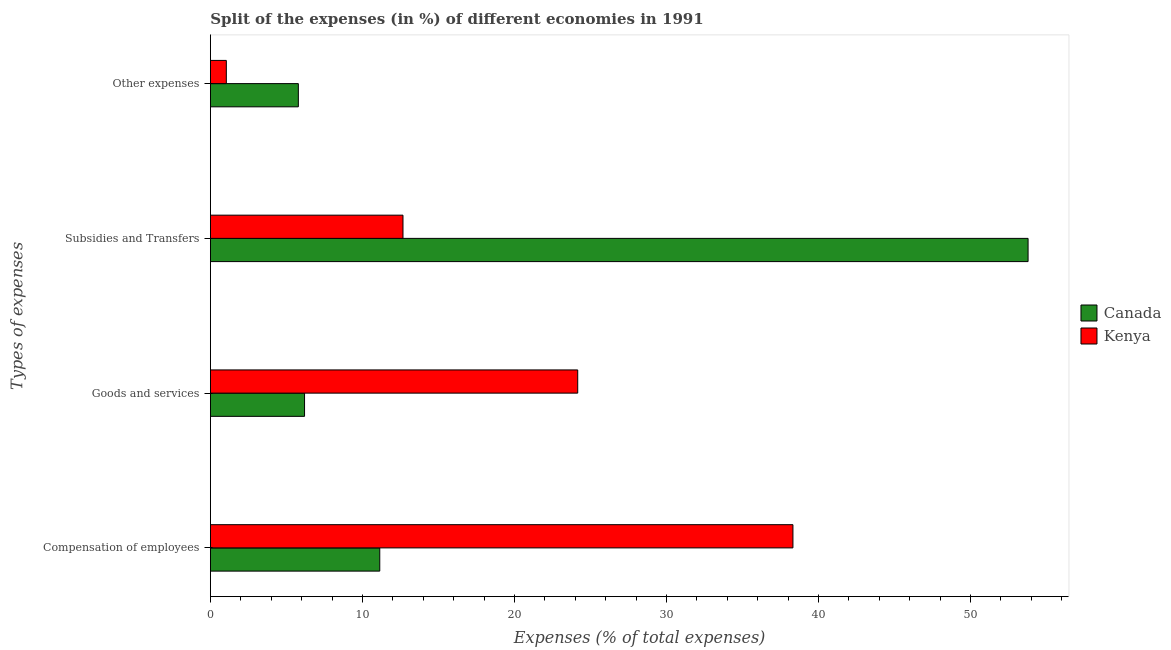Are the number of bars on each tick of the Y-axis equal?
Give a very brief answer. Yes. How many bars are there on the 3rd tick from the top?
Keep it short and to the point. 2. How many bars are there on the 1st tick from the bottom?
Provide a short and direct response. 2. What is the label of the 3rd group of bars from the top?
Your answer should be compact. Goods and services. What is the percentage of amount spent on other expenses in Canada?
Ensure brevity in your answer.  5.79. Across all countries, what is the maximum percentage of amount spent on other expenses?
Offer a terse response. 5.79. Across all countries, what is the minimum percentage of amount spent on other expenses?
Give a very brief answer. 1.05. In which country was the percentage of amount spent on other expenses maximum?
Make the answer very short. Canada. In which country was the percentage of amount spent on goods and services minimum?
Ensure brevity in your answer.  Canada. What is the total percentage of amount spent on subsidies in the graph?
Provide a short and direct response. 66.45. What is the difference between the percentage of amount spent on other expenses in Canada and that in Kenya?
Your answer should be very brief. 4.74. What is the difference between the percentage of amount spent on compensation of employees in Kenya and the percentage of amount spent on goods and services in Canada?
Your answer should be very brief. 32.12. What is the average percentage of amount spent on subsidies per country?
Make the answer very short. 33.23. What is the difference between the percentage of amount spent on subsidies and percentage of amount spent on other expenses in Canada?
Ensure brevity in your answer.  48. In how many countries, is the percentage of amount spent on goods and services greater than 36 %?
Provide a short and direct response. 0. What is the ratio of the percentage of amount spent on compensation of employees in Kenya to that in Canada?
Your response must be concise. 3.44. Is the difference between the percentage of amount spent on goods and services in Canada and Kenya greater than the difference between the percentage of amount spent on other expenses in Canada and Kenya?
Ensure brevity in your answer.  No. What is the difference between the highest and the second highest percentage of amount spent on subsidies?
Make the answer very short. 41.11. What is the difference between the highest and the lowest percentage of amount spent on subsidies?
Offer a very short reply. 41.11. In how many countries, is the percentage of amount spent on other expenses greater than the average percentage of amount spent on other expenses taken over all countries?
Ensure brevity in your answer.  1. Is the sum of the percentage of amount spent on compensation of employees in Canada and Kenya greater than the maximum percentage of amount spent on goods and services across all countries?
Ensure brevity in your answer.  Yes. What does the 2nd bar from the top in Goods and services represents?
Keep it short and to the point. Canada. What does the 2nd bar from the bottom in Subsidies and Transfers represents?
Offer a terse response. Kenya. Is it the case that in every country, the sum of the percentage of amount spent on compensation of employees and percentage of amount spent on goods and services is greater than the percentage of amount spent on subsidies?
Provide a succinct answer. No. Are all the bars in the graph horizontal?
Provide a succinct answer. Yes. How many countries are there in the graph?
Your answer should be compact. 2. Does the graph contain any zero values?
Your answer should be very brief. No. Does the graph contain grids?
Your answer should be compact. No. How many legend labels are there?
Provide a succinct answer. 2. How are the legend labels stacked?
Give a very brief answer. Vertical. What is the title of the graph?
Your response must be concise. Split of the expenses (in %) of different economies in 1991. Does "West Bank and Gaza" appear as one of the legend labels in the graph?
Your answer should be very brief. No. What is the label or title of the X-axis?
Make the answer very short. Expenses (% of total expenses). What is the label or title of the Y-axis?
Your response must be concise. Types of expenses. What is the Expenses (% of total expenses) of Canada in Compensation of employees?
Offer a terse response. 11.14. What is the Expenses (% of total expenses) in Kenya in Compensation of employees?
Make the answer very short. 38.32. What is the Expenses (% of total expenses) of Canada in Goods and services?
Keep it short and to the point. 6.19. What is the Expenses (% of total expenses) in Kenya in Goods and services?
Your answer should be compact. 24.16. What is the Expenses (% of total expenses) in Canada in Subsidies and Transfers?
Provide a succinct answer. 53.78. What is the Expenses (% of total expenses) of Kenya in Subsidies and Transfers?
Keep it short and to the point. 12.67. What is the Expenses (% of total expenses) of Canada in Other expenses?
Offer a terse response. 5.79. What is the Expenses (% of total expenses) in Kenya in Other expenses?
Make the answer very short. 1.05. Across all Types of expenses, what is the maximum Expenses (% of total expenses) in Canada?
Provide a succinct answer. 53.78. Across all Types of expenses, what is the maximum Expenses (% of total expenses) in Kenya?
Offer a terse response. 38.32. Across all Types of expenses, what is the minimum Expenses (% of total expenses) in Canada?
Your response must be concise. 5.79. Across all Types of expenses, what is the minimum Expenses (% of total expenses) in Kenya?
Your response must be concise. 1.05. What is the total Expenses (% of total expenses) in Canada in the graph?
Offer a very short reply. 76.9. What is the total Expenses (% of total expenses) in Kenya in the graph?
Provide a short and direct response. 76.19. What is the difference between the Expenses (% of total expenses) in Canada in Compensation of employees and that in Goods and services?
Your answer should be very brief. 4.95. What is the difference between the Expenses (% of total expenses) in Kenya in Compensation of employees and that in Goods and services?
Keep it short and to the point. 14.16. What is the difference between the Expenses (% of total expenses) of Canada in Compensation of employees and that in Subsidies and Transfers?
Your response must be concise. -42.64. What is the difference between the Expenses (% of total expenses) of Kenya in Compensation of employees and that in Subsidies and Transfers?
Ensure brevity in your answer.  25.65. What is the difference between the Expenses (% of total expenses) in Canada in Compensation of employees and that in Other expenses?
Provide a succinct answer. 5.35. What is the difference between the Expenses (% of total expenses) of Kenya in Compensation of employees and that in Other expenses?
Offer a very short reply. 37.27. What is the difference between the Expenses (% of total expenses) of Canada in Goods and services and that in Subsidies and Transfers?
Your response must be concise. -47.59. What is the difference between the Expenses (% of total expenses) in Kenya in Goods and services and that in Subsidies and Transfers?
Give a very brief answer. 11.49. What is the difference between the Expenses (% of total expenses) of Canada in Goods and services and that in Other expenses?
Your answer should be very brief. 0.41. What is the difference between the Expenses (% of total expenses) in Kenya in Goods and services and that in Other expenses?
Your response must be concise. 23.11. What is the difference between the Expenses (% of total expenses) in Canada in Subsidies and Transfers and that in Other expenses?
Provide a succinct answer. 48. What is the difference between the Expenses (% of total expenses) of Kenya in Subsidies and Transfers and that in Other expenses?
Provide a succinct answer. 11.62. What is the difference between the Expenses (% of total expenses) of Canada in Compensation of employees and the Expenses (% of total expenses) of Kenya in Goods and services?
Your answer should be very brief. -13.02. What is the difference between the Expenses (% of total expenses) of Canada in Compensation of employees and the Expenses (% of total expenses) of Kenya in Subsidies and Transfers?
Your answer should be very brief. -1.53. What is the difference between the Expenses (% of total expenses) of Canada in Compensation of employees and the Expenses (% of total expenses) of Kenya in Other expenses?
Offer a very short reply. 10.09. What is the difference between the Expenses (% of total expenses) of Canada in Goods and services and the Expenses (% of total expenses) of Kenya in Subsidies and Transfers?
Keep it short and to the point. -6.47. What is the difference between the Expenses (% of total expenses) of Canada in Goods and services and the Expenses (% of total expenses) of Kenya in Other expenses?
Ensure brevity in your answer.  5.15. What is the difference between the Expenses (% of total expenses) in Canada in Subsidies and Transfers and the Expenses (% of total expenses) in Kenya in Other expenses?
Give a very brief answer. 52.73. What is the average Expenses (% of total expenses) in Canada per Types of expenses?
Your answer should be very brief. 19.23. What is the average Expenses (% of total expenses) of Kenya per Types of expenses?
Your answer should be very brief. 19.05. What is the difference between the Expenses (% of total expenses) of Canada and Expenses (% of total expenses) of Kenya in Compensation of employees?
Your answer should be very brief. -27.18. What is the difference between the Expenses (% of total expenses) in Canada and Expenses (% of total expenses) in Kenya in Goods and services?
Your answer should be very brief. -17.97. What is the difference between the Expenses (% of total expenses) in Canada and Expenses (% of total expenses) in Kenya in Subsidies and Transfers?
Provide a succinct answer. 41.11. What is the difference between the Expenses (% of total expenses) in Canada and Expenses (% of total expenses) in Kenya in Other expenses?
Ensure brevity in your answer.  4.74. What is the ratio of the Expenses (% of total expenses) in Canada in Compensation of employees to that in Goods and services?
Ensure brevity in your answer.  1.8. What is the ratio of the Expenses (% of total expenses) of Kenya in Compensation of employees to that in Goods and services?
Offer a terse response. 1.59. What is the ratio of the Expenses (% of total expenses) of Canada in Compensation of employees to that in Subsidies and Transfers?
Keep it short and to the point. 0.21. What is the ratio of the Expenses (% of total expenses) in Kenya in Compensation of employees to that in Subsidies and Transfers?
Keep it short and to the point. 3.02. What is the ratio of the Expenses (% of total expenses) in Canada in Compensation of employees to that in Other expenses?
Provide a succinct answer. 1.93. What is the ratio of the Expenses (% of total expenses) of Kenya in Compensation of employees to that in Other expenses?
Keep it short and to the point. 36.56. What is the ratio of the Expenses (% of total expenses) in Canada in Goods and services to that in Subsidies and Transfers?
Keep it short and to the point. 0.12. What is the ratio of the Expenses (% of total expenses) of Kenya in Goods and services to that in Subsidies and Transfers?
Offer a terse response. 1.91. What is the ratio of the Expenses (% of total expenses) of Canada in Goods and services to that in Other expenses?
Give a very brief answer. 1.07. What is the ratio of the Expenses (% of total expenses) in Kenya in Goods and services to that in Other expenses?
Offer a very short reply. 23.05. What is the ratio of the Expenses (% of total expenses) in Canada in Subsidies and Transfers to that in Other expenses?
Your response must be concise. 9.3. What is the ratio of the Expenses (% of total expenses) in Kenya in Subsidies and Transfers to that in Other expenses?
Give a very brief answer. 12.09. What is the difference between the highest and the second highest Expenses (% of total expenses) in Canada?
Your response must be concise. 42.64. What is the difference between the highest and the second highest Expenses (% of total expenses) of Kenya?
Offer a very short reply. 14.16. What is the difference between the highest and the lowest Expenses (% of total expenses) in Canada?
Give a very brief answer. 48. What is the difference between the highest and the lowest Expenses (% of total expenses) of Kenya?
Your answer should be very brief. 37.27. 